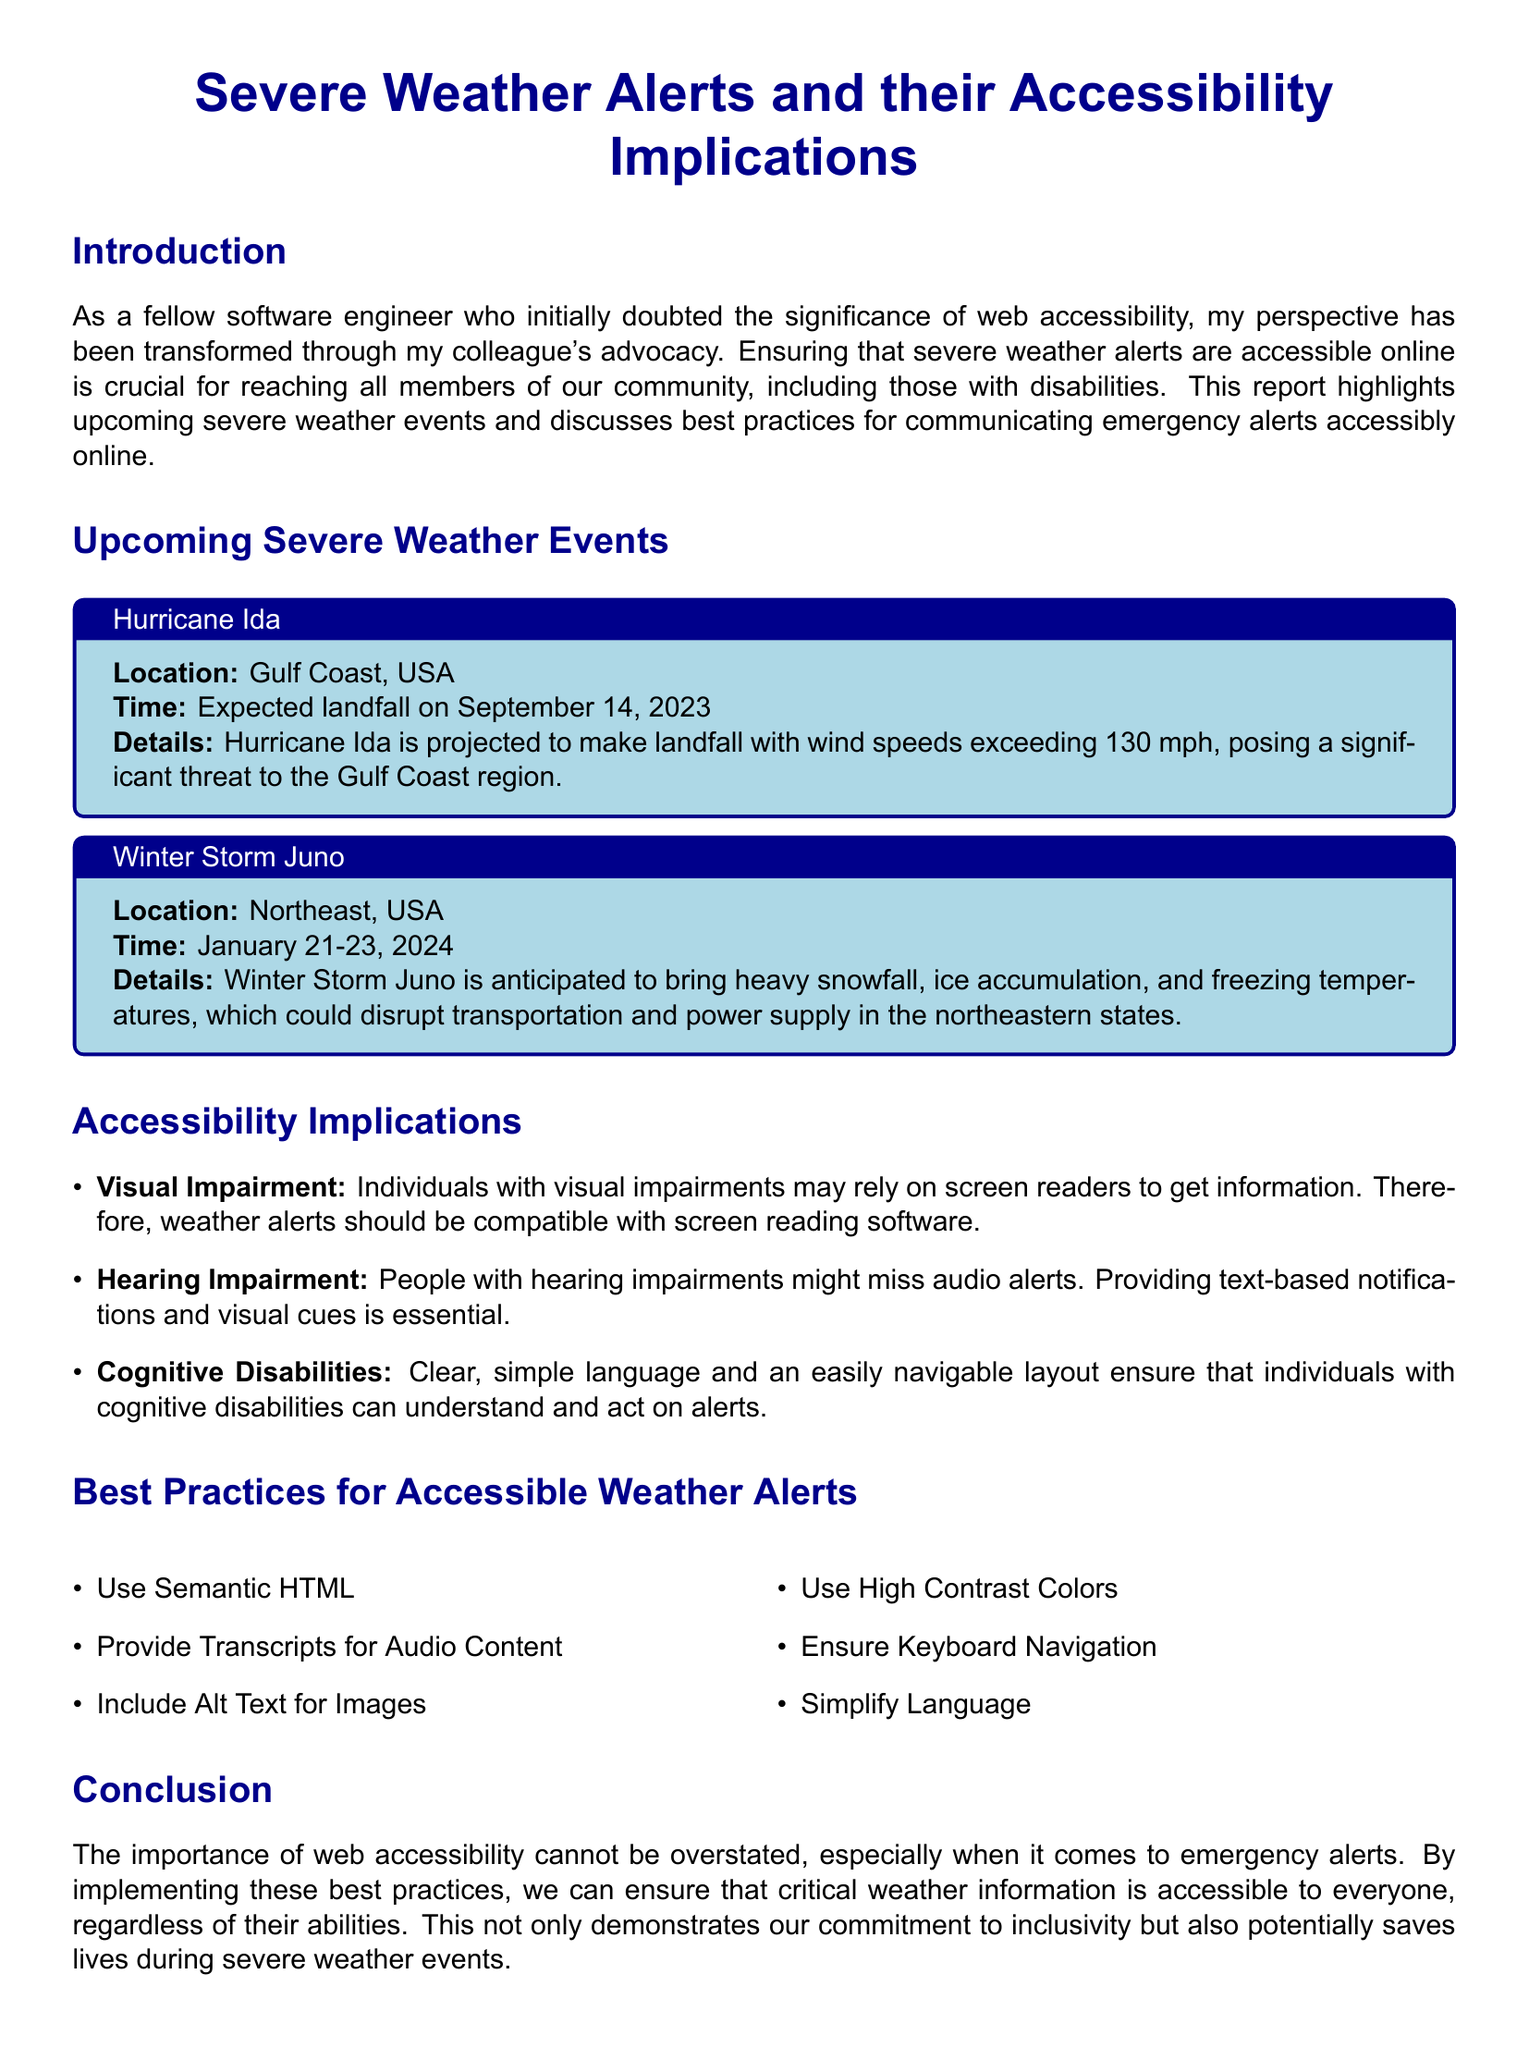What is the title of the document? The title is prominently displayed at the center of the document, indicating the main topic it addresses.
Answer: Severe Weather Alerts and their Accessibility Implications When is Hurricane Ida expected to make landfall? The document states the expected landfall date for Hurricane Ida clearly under the event details.
Answer: September 14, 2023 What region will Winter Storm Juno affect? The document specifies the geographical area impacted by Winter Storm Juno in its event box.
Answer: Northeast, USA What type of severe weather is associated with Winter Storm Juno? The details provided in the event box describe the weather conditions expected with Winter Storm Juno.
Answer: Heavy snowfall, ice accumulation, and freezing temperatures Which accessibility challenge is related to visual impairment? The document mentions specific challenges faced by individuals with visual impairments under the accessibility implications section.
Answer: Screen readers What is one best practice for accessible weather alerts? The document lists several best practices to ensure accessibility, indicating a key recommendation.
Answer: Use Semantic HTML How does the report suggest to help individuals with cognitive disabilities? The document outlines the necessary adjustments to ensure the information is clear for people with cognitive disabilities.
Answer: Simplify language What color contrasts are recommended for accessibility in weather alerts? The report emphasizes the importance of color contrast to aid visibility in the best practices section.
Answer: High contrast colors 